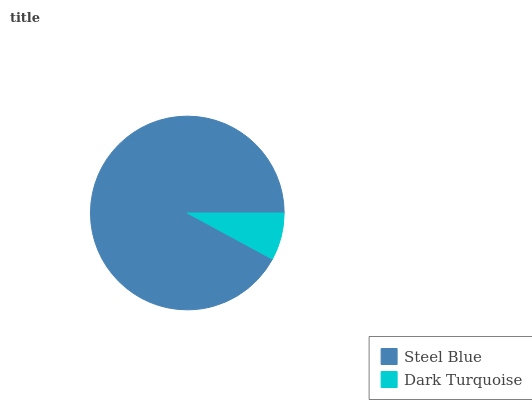Is Dark Turquoise the minimum?
Answer yes or no. Yes. Is Steel Blue the maximum?
Answer yes or no. Yes. Is Dark Turquoise the maximum?
Answer yes or no. No. Is Steel Blue greater than Dark Turquoise?
Answer yes or no. Yes. Is Dark Turquoise less than Steel Blue?
Answer yes or no. Yes. Is Dark Turquoise greater than Steel Blue?
Answer yes or no. No. Is Steel Blue less than Dark Turquoise?
Answer yes or no. No. Is Steel Blue the high median?
Answer yes or no. Yes. Is Dark Turquoise the low median?
Answer yes or no. Yes. Is Dark Turquoise the high median?
Answer yes or no. No. Is Steel Blue the low median?
Answer yes or no. No. 